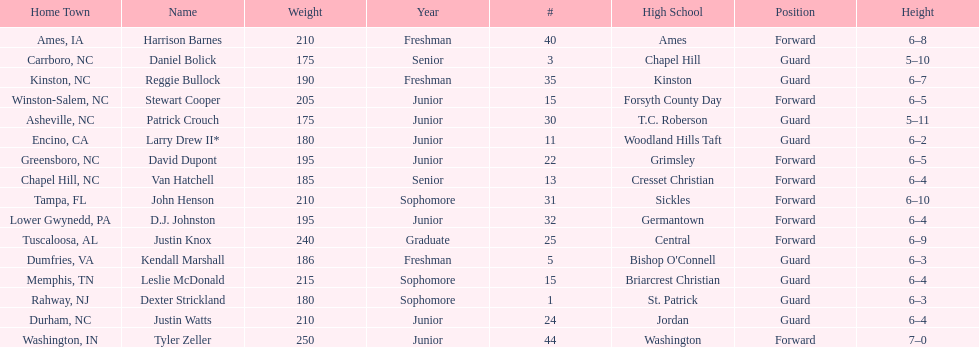Names of players who were exactly 6 feet, 4 inches tall, but did not weight over 200 pounds Van Hatchell, D.J. Johnston. 